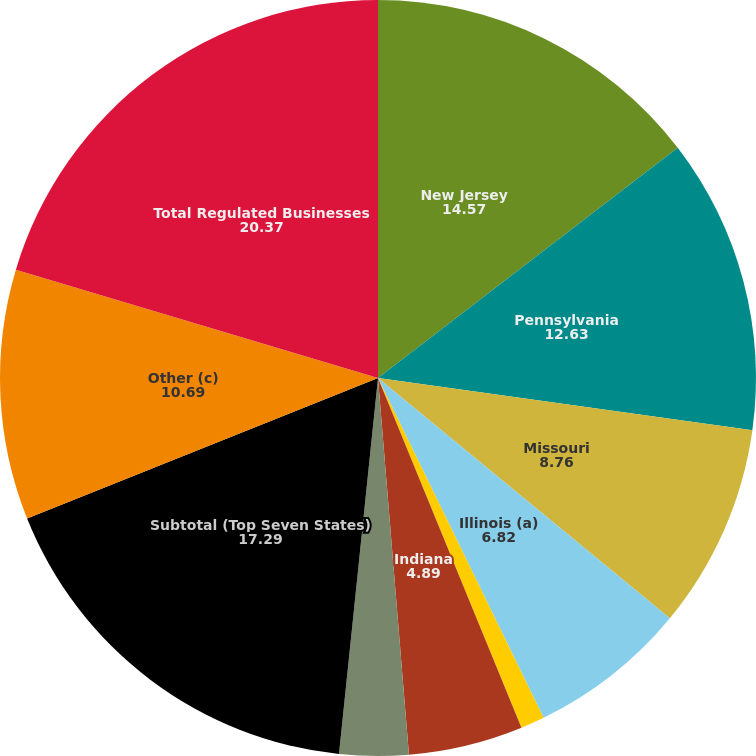Convert chart to OTSL. <chart><loc_0><loc_0><loc_500><loc_500><pie_chart><fcel>New Jersey<fcel>Pennsylvania<fcel>Missouri<fcel>Illinois (a)<fcel>California<fcel>Indiana<fcel>West Virginia (b)<fcel>Subtotal (Top Seven States)<fcel>Other (c)<fcel>Total Regulated Businesses<nl><fcel>14.57%<fcel>12.63%<fcel>8.76%<fcel>6.82%<fcel>1.02%<fcel>4.89%<fcel>2.95%<fcel>17.29%<fcel>10.69%<fcel>20.37%<nl></chart> 